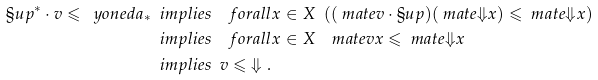<formula> <loc_0><loc_0><loc_500><loc_500>\S u p ^ { * } \cdot v \leqslant \ y o n e d a _ { * } & \ \ i m p l i e s \quad f o r a l l x \in X \ \ ( ( \ m a t e { v } \cdot \S u p ) ( \ m a t e { \Downarrow } x ) \leqslant \ m a t e { \Downarrow } x ) \\ & \ \ i m p l i e s \quad f o r a l l x \in X \quad m a t e { v } x \leqslant \ m a t e { \Downarrow } x \\ & \ \ i m p l i e s \ \ v \leqslant \ \Downarrow .</formula> 